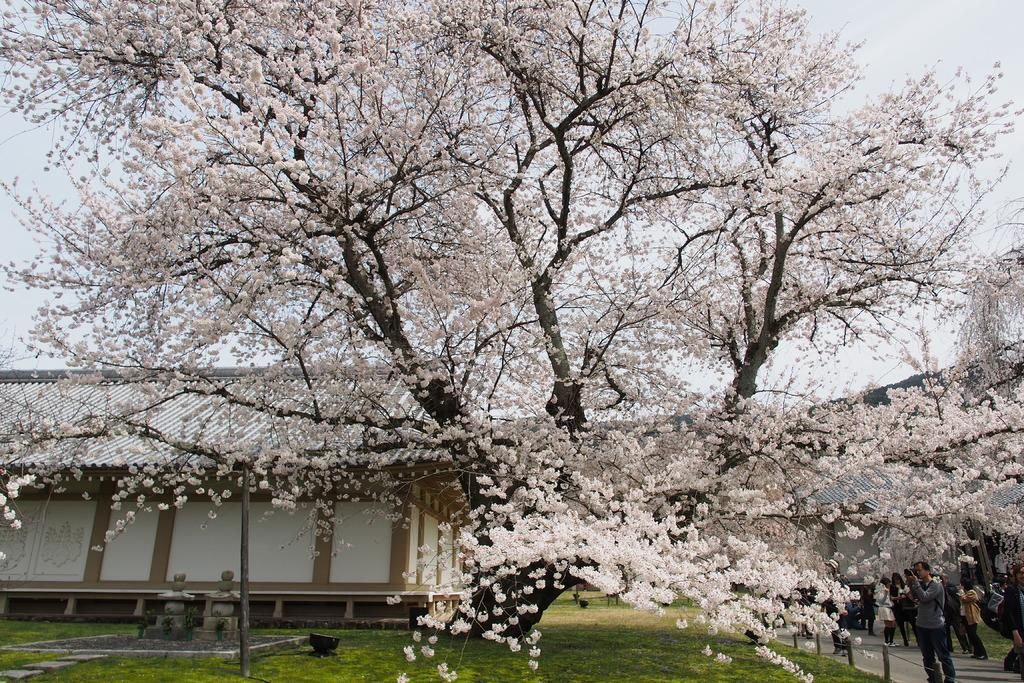What type of vegetation covers the land in the image? The land in the image is covered with grass. Where are the people located in the image? The people are on the right side of the image. Can you describe the house in the image? The house is located behind a tree in the image. What type of drink is being served from the crate in the image? There is no crate or drink present in the image. 